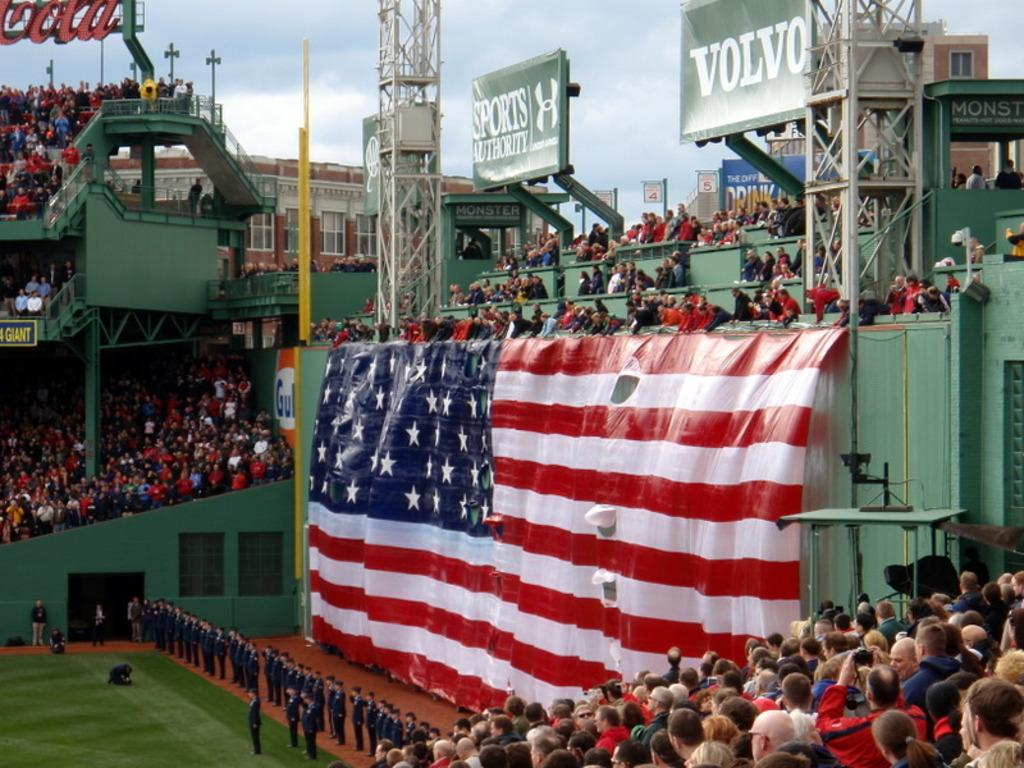<image>
Offer a succinct explanation of the picture presented. A huge American flag with Volvo and Sports Authority banners above it. 